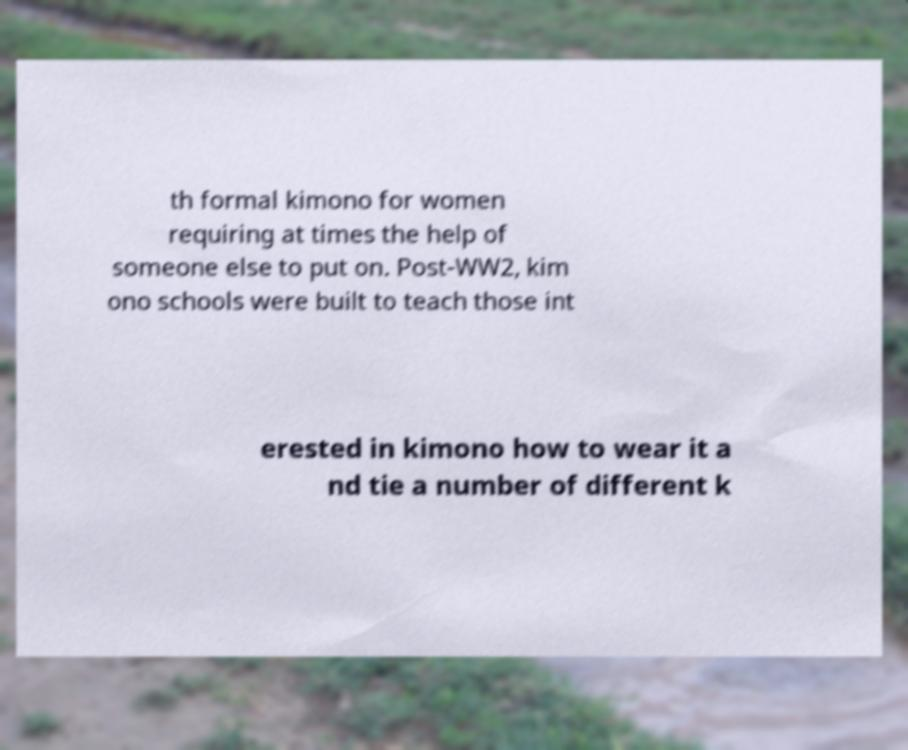Please identify and transcribe the text found in this image. th formal kimono for women requiring at times the help of someone else to put on. Post-WW2, kim ono schools were built to teach those int erested in kimono how to wear it a nd tie a number of different k 